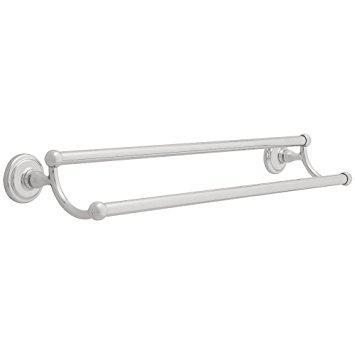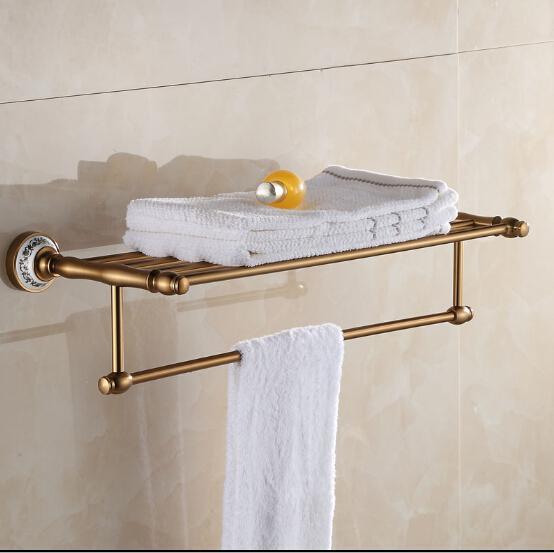The first image is the image on the left, the second image is the image on the right. For the images shown, is this caption "One of the racks has nothing on it." true? Answer yes or no. Yes. 